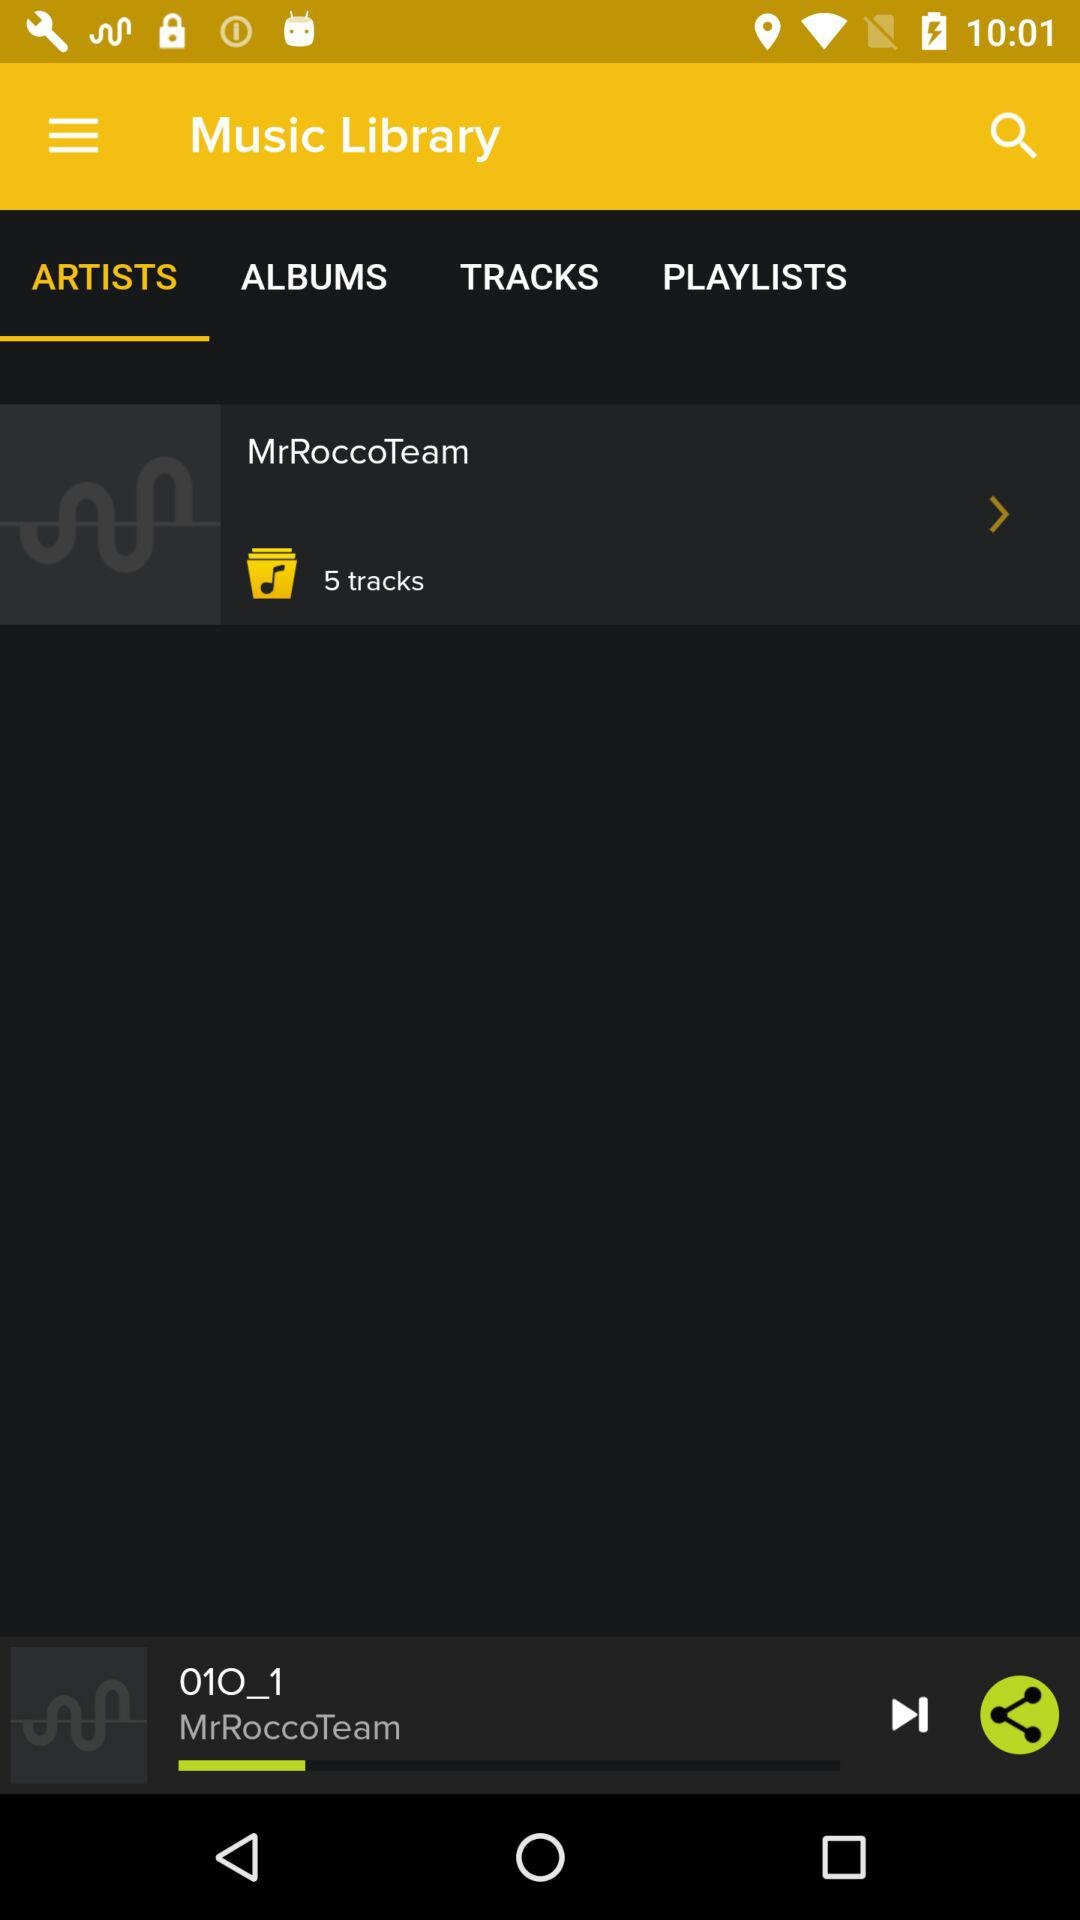How many tracks are in the album with the most tracks?
Answer the question using a single word or phrase. 5 